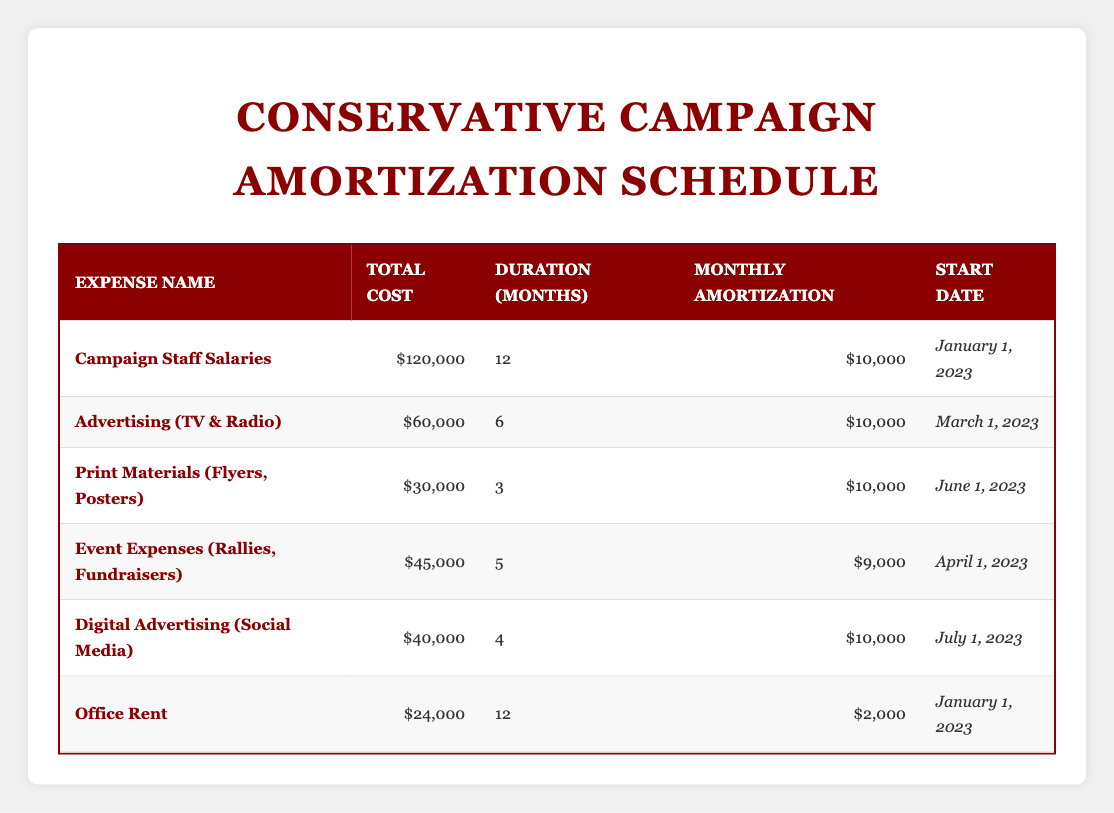What is the total cost of Campaign Staff Salaries? The table states that the total cost for Campaign Staff Salaries is listed directly under the Total Cost column for that expense, which is $120,000.
Answer: $120,000 How many months is the Advertising (TV & Radio) expense amortized over? The table specifies the duration for Advertising (TV & Radio) is listed under Duration (Months), which is 6 months.
Answer: 6 months What is the monthly amortization for Event Expenses? According to the table, the monthly amortization for Event Expenses (Rallies, Fundraisers) is clearly indicated in the Monthly Amortization column, which is $9,000.
Answer: $9,000 Are the Office Rent and Campaign Staff Salaries expenses amortized over the same duration? Looking at the Duration (Months) column, Office Rent has a duration of 12 months while Campaign Staff Salaries also has a duration of 12 months. Since both durations are equal, the answer is yes.
Answer: Yes What is the total cost for Digital Advertising (Social Media) and Print Materials (Flyers, Posters) combined? To find the total, we add the costs from the Total Cost column: Digital Advertising is $40,000 and Print Materials is $30,000. Therefore, the combined total is $40,000 + $30,000 = $70,000.
Answer: $70,000 Which expenditure has the highest monthly amortization? By reviewing the Monthly Amortization column, the highest value is found under Campaign Staff Salaries and Advertising (TV & Radio), both at $10,000. Thus, multiple expenditures have the same highest monthly amortization.
Answer: Campaign Staff Salaries and Advertising (TV & Radio) What is the average monthly amortization across all listed expenses? The monthly amortization values are $10,000 (Campaign Staff), $10,000 (Advertising), $10,000 (Print Materials), $9,000 (Event Expenses), $10,000 (Digital Advertising), and $2,000 (Office Rent). The total is $10,000 + $10,000 + $10,000 + $9,000 + $10,000 + $2,000 = $51,000. There are 6 expenses, so the average is $51,000 / 6 = $8,500.
Answer: $8,500 Is the total cost of Event Expenses less than or equal to the total cost of Print Materials? The total cost for Event Expenses (Rallies, Fundraisers) is $45,000 and for Print Materials (Flyers, Posters) is $30,000. Since $45,000 is greater than $30,000, the answer is no.
Answer: No How many expenses have a monthly amortization of $10,000? Reviewing the Monthly Amortization column, Campaign Staff Salaries, Advertising (TV & Radio), Digital Advertising, and Print Materials each have a monthly amortization of $10,000. That counts to 4 expenses.
Answer: 4 